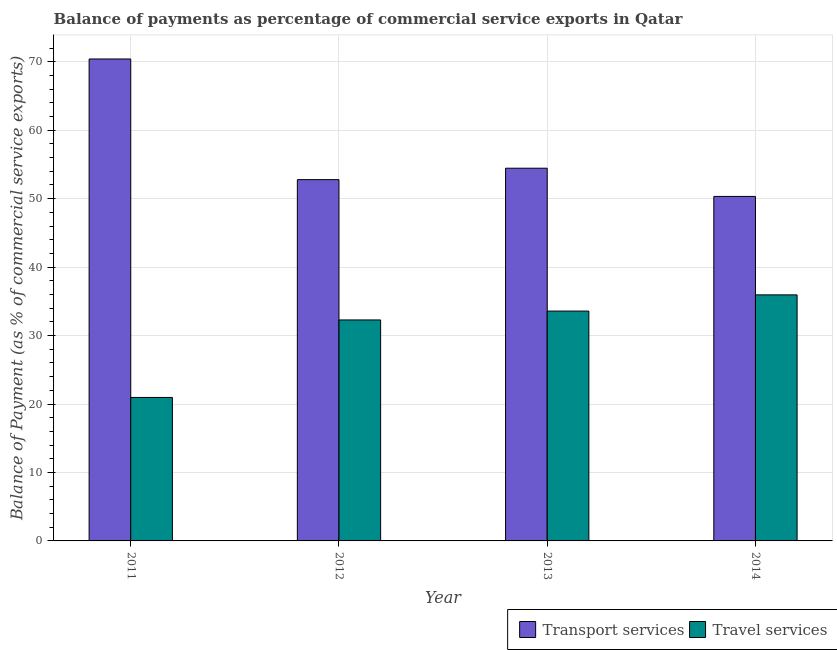How many different coloured bars are there?
Keep it short and to the point. 2. Are the number of bars per tick equal to the number of legend labels?
Ensure brevity in your answer.  Yes. How many bars are there on the 2nd tick from the left?
Make the answer very short. 2. What is the label of the 1st group of bars from the left?
Keep it short and to the point. 2011. What is the balance of payments of travel services in 2011?
Provide a short and direct response. 20.96. Across all years, what is the maximum balance of payments of travel services?
Ensure brevity in your answer.  35.94. Across all years, what is the minimum balance of payments of travel services?
Provide a succinct answer. 20.96. What is the total balance of payments of travel services in the graph?
Ensure brevity in your answer.  122.75. What is the difference between the balance of payments of transport services in 2012 and that in 2013?
Offer a very short reply. -1.67. What is the difference between the balance of payments of travel services in 2011 and the balance of payments of transport services in 2014?
Provide a succinct answer. -14.98. What is the average balance of payments of transport services per year?
Keep it short and to the point. 56.99. In how many years, is the balance of payments of travel services greater than 12 %?
Offer a terse response. 4. What is the ratio of the balance of payments of transport services in 2013 to that in 2014?
Keep it short and to the point. 1.08. Is the balance of payments of transport services in 2012 less than that in 2014?
Keep it short and to the point. No. What is the difference between the highest and the second highest balance of payments of travel services?
Make the answer very short. 2.37. What is the difference between the highest and the lowest balance of payments of transport services?
Ensure brevity in your answer.  20.08. Is the sum of the balance of payments of travel services in 2011 and 2013 greater than the maximum balance of payments of transport services across all years?
Offer a very short reply. Yes. What does the 2nd bar from the left in 2011 represents?
Keep it short and to the point. Travel services. What does the 1st bar from the right in 2012 represents?
Give a very brief answer. Travel services. How many bars are there?
Provide a short and direct response. 8. Are all the bars in the graph horizontal?
Offer a terse response. No. What is the difference between two consecutive major ticks on the Y-axis?
Provide a short and direct response. 10. Are the values on the major ticks of Y-axis written in scientific E-notation?
Keep it short and to the point. No. Does the graph contain any zero values?
Provide a short and direct response. No. How are the legend labels stacked?
Keep it short and to the point. Horizontal. What is the title of the graph?
Your answer should be very brief. Balance of payments as percentage of commercial service exports in Qatar. Does "Export" appear as one of the legend labels in the graph?
Give a very brief answer. No. What is the label or title of the X-axis?
Make the answer very short. Year. What is the label or title of the Y-axis?
Your response must be concise. Balance of Payment (as % of commercial service exports). What is the Balance of Payment (as % of commercial service exports) in Transport services in 2011?
Offer a very short reply. 70.4. What is the Balance of Payment (as % of commercial service exports) in Travel services in 2011?
Offer a terse response. 20.96. What is the Balance of Payment (as % of commercial service exports) in Transport services in 2012?
Your response must be concise. 52.78. What is the Balance of Payment (as % of commercial service exports) of Travel services in 2012?
Give a very brief answer. 32.28. What is the Balance of Payment (as % of commercial service exports) of Transport services in 2013?
Give a very brief answer. 54.45. What is the Balance of Payment (as % of commercial service exports) in Travel services in 2013?
Your answer should be very brief. 33.57. What is the Balance of Payment (as % of commercial service exports) of Transport services in 2014?
Your answer should be very brief. 50.32. What is the Balance of Payment (as % of commercial service exports) in Travel services in 2014?
Your answer should be very brief. 35.94. Across all years, what is the maximum Balance of Payment (as % of commercial service exports) in Transport services?
Give a very brief answer. 70.4. Across all years, what is the maximum Balance of Payment (as % of commercial service exports) of Travel services?
Your response must be concise. 35.94. Across all years, what is the minimum Balance of Payment (as % of commercial service exports) of Transport services?
Your answer should be compact. 50.32. Across all years, what is the minimum Balance of Payment (as % of commercial service exports) of Travel services?
Provide a succinct answer. 20.96. What is the total Balance of Payment (as % of commercial service exports) of Transport services in the graph?
Give a very brief answer. 227.95. What is the total Balance of Payment (as % of commercial service exports) of Travel services in the graph?
Your answer should be compact. 122.75. What is the difference between the Balance of Payment (as % of commercial service exports) in Transport services in 2011 and that in 2012?
Provide a succinct answer. 17.63. What is the difference between the Balance of Payment (as % of commercial service exports) in Travel services in 2011 and that in 2012?
Your response must be concise. -11.32. What is the difference between the Balance of Payment (as % of commercial service exports) in Transport services in 2011 and that in 2013?
Ensure brevity in your answer.  15.96. What is the difference between the Balance of Payment (as % of commercial service exports) of Travel services in 2011 and that in 2013?
Give a very brief answer. -12.62. What is the difference between the Balance of Payment (as % of commercial service exports) of Transport services in 2011 and that in 2014?
Make the answer very short. 20.08. What is the difference between the Balance of Payment (as % of commercial service exports) in Travel services in 2011 and that in 2014?
Make the answer very short. -14.98. What is the difference between the Balance of Payment (as % of commercial service exports) of Transport services in 2012 and that in 2013?
Your answer should be compact. -1.67. What is the difference between the Balance of Payment (as % of commercial service exports) of Travel services in 2012 and that in 2013?
Offer a very short reply. -1.3. What is the difference between the Balance of Payment (as % of commercial service exports) in Transport services in 2012 and that in 2014?
Your answer should be very brief. 2.45. What is the difference between the Balance of Payment (as % of commercial service exports) of Travel services in 2012 and that in 2014?
Your answer should be compact. -3.66. What is the difference between the Balance of Payment (as % of commercial service exports) in Transport services in 2013 and that in 2014?
Your answer should be very brief. 4.12. What is the difference between the Balance of Payment (as % of commercial service exports) of Travel services in 2013 and that in 2014?
Offer a very short reply. -2.37. What is the difference between the Balance of Payment (as % of commercial service exports) of Transport services in 2011 and the Balance of Payment (as % of commercial service exports) of Travel services in 2012?
Your answer should be very brief. 38.12. What is the difference between the Balance of Payment (as % of commercial service exports) in Transport services in 2011 and the Balance of Payment (as % of commercial service exports) in Travel services in 2013?
Your answer should be very brief. 36.83. What is the difference between the Balance of Payment (as % of commercial service exports) of Transport services in 2011 and the Balance of Payment (as % of commercial service exports) of Travel services in 2014?
Provide a succinct answer. 34.46. What is the difference between the Balance of Payment (as % of commercial service exports) of Transport services in 2012 and the Balance of Payment (as % of commercial service exports) of Travel services in 2013?
Offer a very short reply. 19.2. What is the difference between the Balance of Payment (as % of commercial service exports) in Transport services in 2012 and the Balance of Payment (as % of commercial service exports) in Travel services in 2014?
Your answer should be compact. 16.83. What is the difference between the Balance of Payment (as % of commercial service exports) in Transport services in 2013 and the Balance of Payment (as % of commercial service exports) in Travel services in 2014?
Your answer should be very brief. 18.5. What is the average Balance of Payment (as % of commercial service exports) in Transport services per year?
Ensure brevity in your answer.  56.99. What is the average Balance of Payment (as % of commercial service exports) in Travel services per year?
Your answer should be very brief. 30.69. In the year 2011, what is the difference between the Balance of Payment (as % of commercial service exports) of Transport services and Balance of Payment (as % of commercial service exports) of Travel services?
Provide a short and direct response. 49.44. In the year 2012, what is the difference between the Balance of Payment (as % of commercial service exports) in Transport services and Balance of Payment (as % of commercial service exports) in Travel services?
Provide a succinct answer. 20.5. In the year 2013, what is the difference between the Balance of Payment (as % of commercial service exports) of Transport services and Balance of Payment (as % of commercial service exports) of Travel services?
Provide a succinct answer. 20.87. In the year 2014, what is the difference between the Balance of Payment (as % of commercial service exports) in Transport services and Balance of Payment (as % of commercial service exports) in Travel services?
Give a very brief answer. 14.38. What is the ratio of the Balance of Payment (as % of commercial service exports) of Transport services in 2011 to that in 2012?
Give a very brief answer. 1.33. What is the ratio of the Balance of Payment (as % of commercial service exports) in Travel services in 2011 to that in 2012?
Your answer should be compact. 0.65. What is the ratio of the Balance of Payment (as % of commercial service exports) in Transport services in 2011 to that in 2013?
Offer a very short reply. 1.29. What is the ratio of the Balance of Payment (as % of commercial service exports) of Travel services in 2011 to that in 2013?
Offer a very short reply. 0.62. What is the ratio of the Balance of Payment (as % of commercial service exports) of Transport services in 2011 to that in 2014?
Give a very brief answer. 1.4. What is the ratio of the Balance of Payment (as % of commercial service exports) of Travel services in 2011 to that in 2014?
Your response must be concise. 0.58. What is the ratio of the Balance of Payment (as % of commercial service exports) of Transport services in 2012 to that in 2013?
Keep it short and to the point. 0.97. What is the ratio of the Balance of Payment (as % of commercial service exports) in Travel services in 2012 to that in 2013?
Offer a terse response. 0.96. What is the ratio of the Balance of Payment (as % of commercial service exports) of Transport services in 2012 to that in 2014?
Provide a succinct answer. 1.05. What is the ratio of the Balance of Payment (as % of commercial service exports) in Travel services in 2012 to that in 2014?
Your answer should be compact. 0.9. What is the ratio of the Balance of Payment (as % of commercial service exports) of Transport services in 2013 to that in 2014?
Ensure brevity in your answer.  1.08. What is the ratio of the Balance of Payment (as % of commercial service exports) of Travel services in 2013 to that in 2014?
Your answer should be compact. 0.93. What is the difference between the highest and the second highest Balance of Payment (as % of commercial service exports) of Transport services?
Ensure brevity in your answer.  15.96. What is the difference between the highest and the second highest Balance of Payment (as % of commercial service exports) in Travel services?
Your response must be concise. 2.37. What is the difference between the highest and the lowest Balance of Payment (as % of commercial service exports) of Transport services?
Give a very brief answer. 20.08. What is the difference between the highest and the lowest Balance of Payment (as % of commercial service exports) in Travel services?
Ensure brevity in your answer.  14.98. 